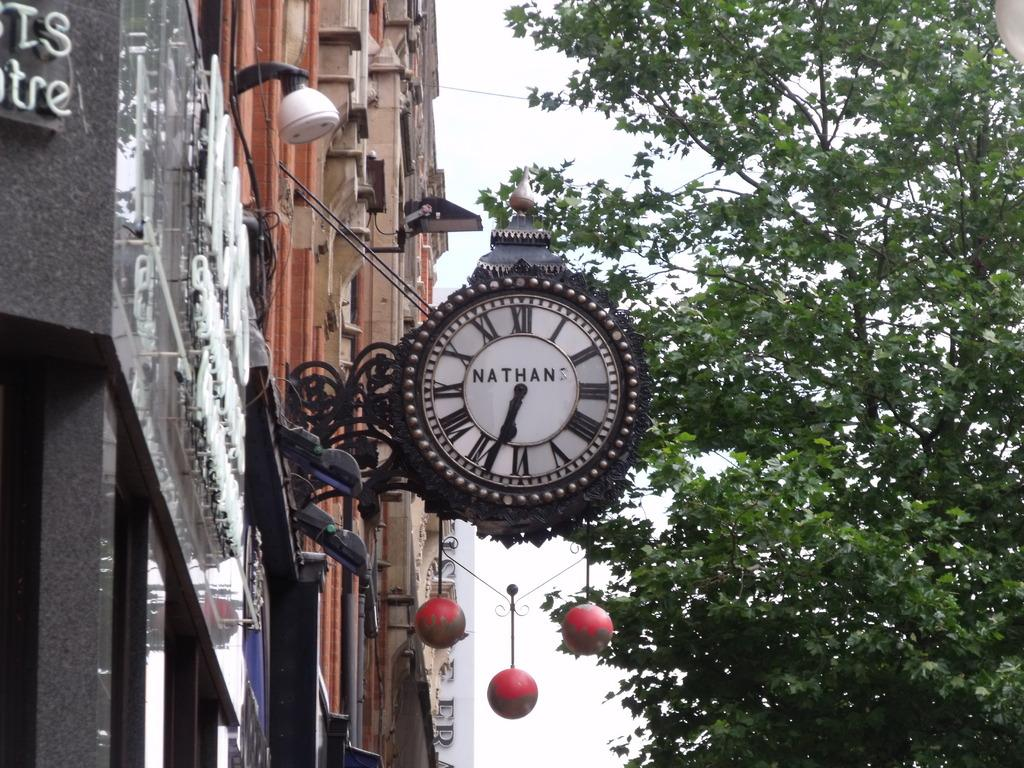<image>
Offer a succinct explanation of the picture presented. A Nathan clock on a building shows the time of 6:33. 